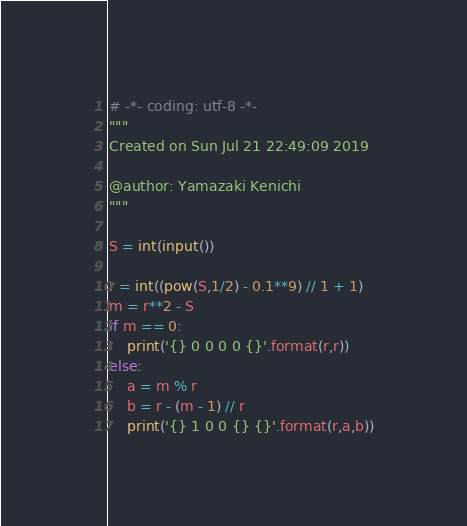<code> <loc_0><loc_0><loc_500><loc_500><_Python_># -*- coding: utf-8 -*-
"""
Created on Sun Jul 21 22:49:09 2019

@author: Yamazaki Kenichi
"""

S = int(input())

r = int((pow(S,1/2) - 0.1**9) // 1 + 1)
m = r**2 - S
if m == 0:
    print('{} 0 0 0 0 {}'.format(r,r))
else:
    a = m % r
    b = r - (m - 1) // r
    print('{} 1 0 0 {} {}'.format(r,a,b))</code> 